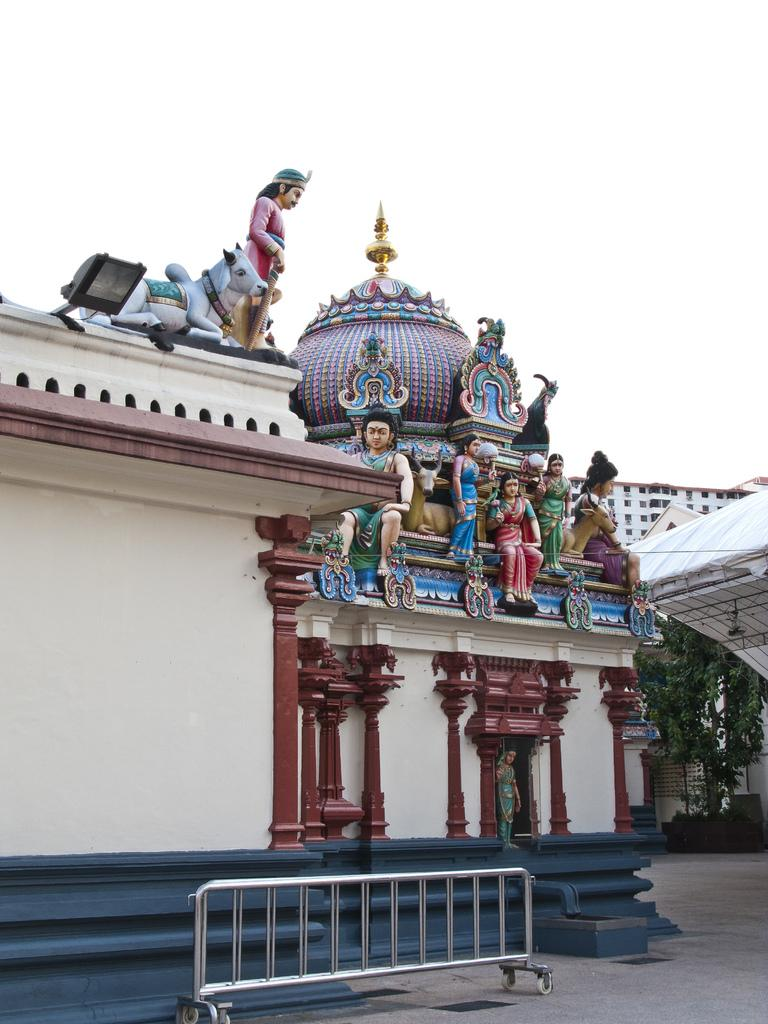What type of objects can be seen in the image? There are metal rods in the image. What can be used for illumination in the image? There is a light in the image. What type of structure is present in the image? There is a temple in the image. What type of natural elements can be seen in the background of the image? There are trees in the background of the image. What type of man-made structure can be seen in the background of the image? There is a building in the background of the image. What type of twig is being used to act as a cracker in the image? There is no twig or cracker present in the image. 